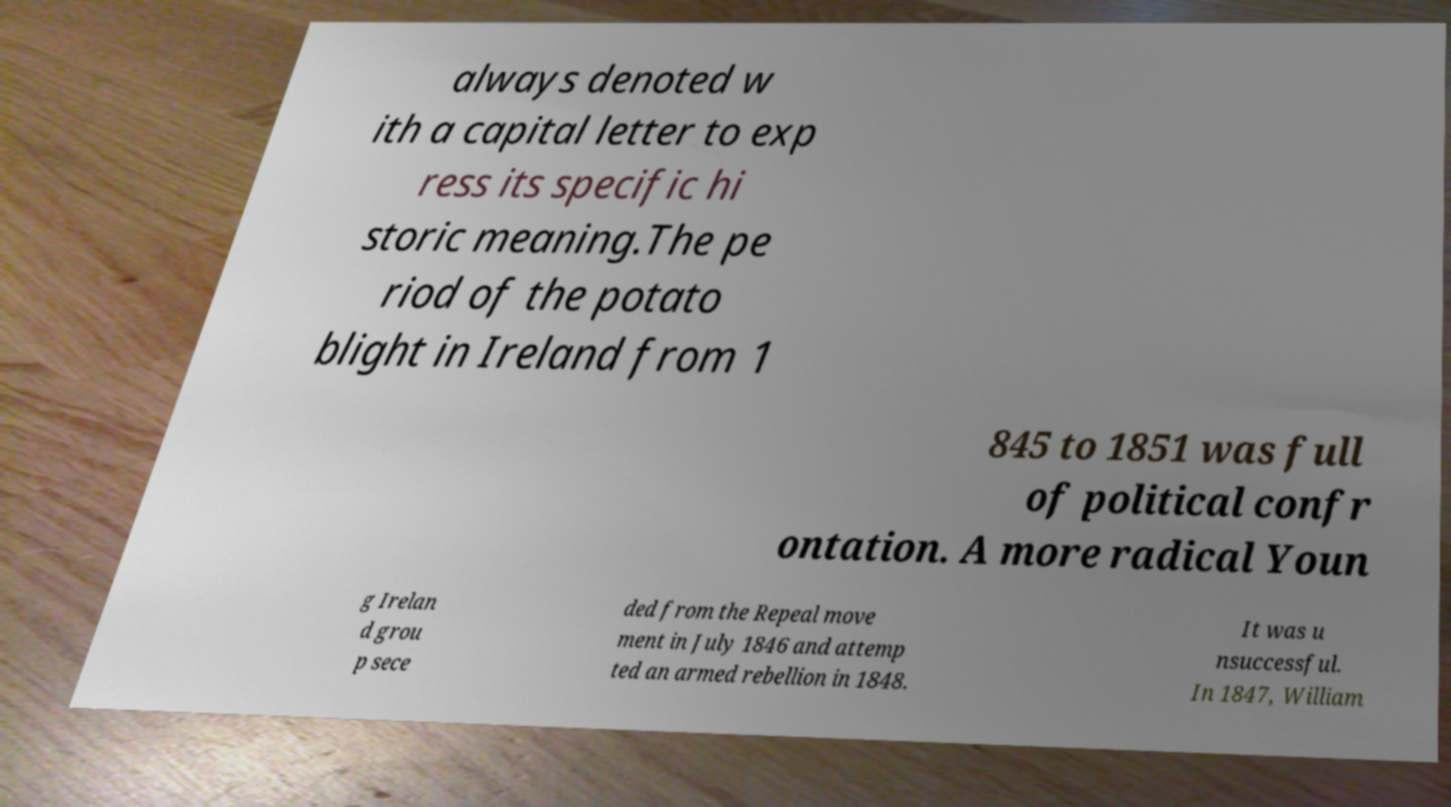Can you read and provide the text displayed in the image?This photo seems to have some interesting text. Can you extract and type it out for me? always denoted w ith a capital letter to exp ress its specific hi storic meaning.The pe riod of the potato blight in Ireland from 1 845 to 1851 was full of political confr ontation. A more radical Youn g Irelan d grou p sece ded from the Repeal move ment in July 1846 and attemp ted an armed rebellion in 1848. It was u nsuccessful. In 1847, William 